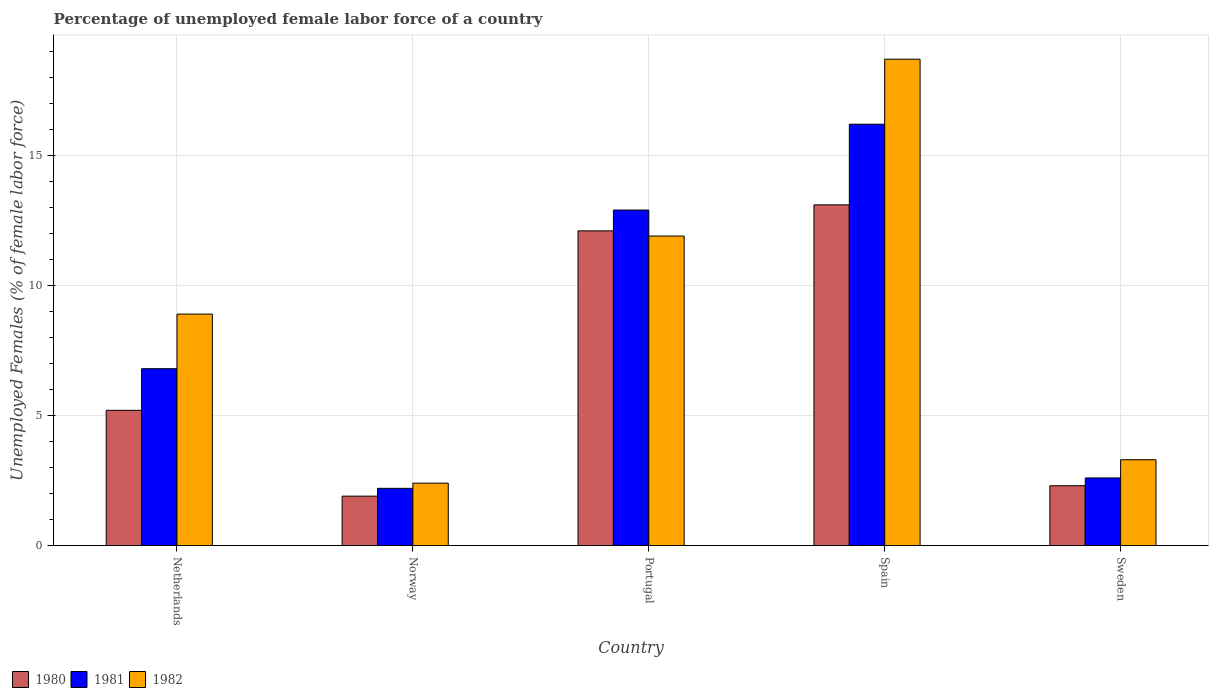How many groups of bars are there?
Ensure brevity in your answer.  5. Are the number of bars on each tick of the X-axis equal?
Provide a succinct answer. Yes. In how many cases, is the number of bars for a given country not equal to the number of legend labels?
Your response must be concise. 0. What is the percentage of unemployed female labor force in 1981 in Spain?
Provide a short and direct response. 16.2. Across all countries, what is the maximum percentage of unemployed female labor force in 1981?
Offer a very short reply. 16.2. Across all countries, what is the minimum percentage of unemployed female labor force in 1982?
Provide a succinct answer. 2.4. What is the total percentage of unemployed female labor force in 1980 in the graph?
Keep it short and to the point. 34.6. What is the difference between the percentage of unemployed female labor force in 1980 in Portugal and that in Sweden?
Provide a short and direct response. 9.8. What is the difference between the percentage of unemployed female labor force in 1982 in Spain and the percentage of unemployed female labor force in 1980 in Norway?
Make the answer very short. 16.8. What is the average percentage of unemployed female labor force in 1981 per country?
Ensure brevity in your answer.  8.14. What is the difference between the percentage of unemployed female labor force of/in 1980 and percentage of unemployed female labor force of/in 1981 in Norway?
Your response must be concise. -0.3. What is the ratio of the percentage of unemployed female labor force in 1982 in Portugal to that in Spain?
Offer a terse response. 0.64. What is the difference between the highest and the second highest percentage of unemployed female labor force in 1981?
Keep it short and to the point. 3.3. What is the difference between the highest and the lowest percentage of unemployed female labor force in 1981?
Offer a terse response. 14. What does the 2nd bar from the right in Portugal represents?
Your answer should be compact. 1981. How many bars are there?
Make the answer very short. 15. How many countries are there in the graph?
Offer a terse response. 5. Does the graph contain grids?
Offer a terse response. Yes. Where does the legend appear in the graph?
Keep it short and to the point. Bottom left. What is the title of the graph?
Ensure brevity in your answer.  Percentage of unemployed female labor force of a country. What is the label or title of the Y-axis?
Your answer should be very brief. Unemployed Females (% of female labor force). What is the Unemployed Females (% of female labor force) in 1980 in Netherlands?
Your answer should be compact. 5.2. What is the Unemployed Females (% of female labor force) in 1981 in Netherlands?
Your answer should be compact. 6.8. What is the Unemployed Females (% of female labor force) of 1982 in Netherlands?
Your answer should be compact. 8.9. What is the Unemployed Females (% of female labor force) of 1980 in Norway?
Your response must be concise. 1.9. What is the Unemployed Females (% of female labor force) in 1981 in Norway?
Give a very brief answer. 2.2. What is the Unemployed Females (% of female labor force) in 1982 in Norway?
Make the answer very short. 2.4. What is the Unemployed Females (% of female labor force) in 1980 in Portugal?
Give a very brief answer. 12.1. What is the Unemployed Females (% of female labor force) in 1981 in Portugal?
Your answer should be compact. 12.9. What is the Unemployed Females (% of female labor force) in 1982 in Portugal?
Your response must be concise. 11.9. What is the Unemployed Females (% of female labor force) in 1980 in Spain?
Your answer should be compact. 13.1. What is the Unemployed Females (% of female labor force) of 1981 in Spain?
Your response must be concise. 16.2. What is the Unemployed Females (% of female labor force) of 1982 in Spain?
Offer a terse response. 18.7. What is the Unemployed Females (% of female labor force) in 1980 in Sweden?
Offer a very short reply. 2.3. What is the Unemployed Females (% of female labor force) of 1981 in Sweden?
Give a very brief answer. 2.6. What is the Unemployed Females (% of female labor force) in 1982 in Sweden?
Provide a short and direct response. 3.3. Across all countries, what is the maximum Unemployed Females (% of female labor force) of 1980?
Provide a succinct answer. 13.1. Across all countries, what is the maximum Unemployed Females (% of female labor force) in 1981?
Provide a short and direct response. 16.2. Across all countries, what is the maximum Unemployed Females (% of female labor force) in 1982?
Provide a short and direct response. 18.7. Across all countries, what is the minimum Unemployed Females (% of female labor force) of 1980?
Offer a terse response. 1.9. Across all countries, what is the minimum Unemployed Females (% of female labor force) of 1981?
Ensure brevity in your answer.  2.2. Across all countries, what is the minimum Unemployed Females (% of female labor force) in 1982?
Provide a short and direct response. 2.4. What is the total Unemployed Females (% of female labor force) in 1980 in the graph?
Your response must be concise. 34.6. What is the total Unemployed Females (% of female labor force) in 1981 in the graph?
Make the answer very short. 40.7. What is the total Unemployed Females (% of female labor force) of 1982 in the graph?
Your response must be concise. 45.2. What is the difference between the Unemployed Females (% of female labor force) of 1982 in Netherlands and that in Norway?
Give a very brief answer. 6.5. What is the difference between the Unemployed Females (% of female labor force) in 1980 in Netherlands and that in Portugal?
Your response must be concise. -6.9. What is the difference between the Unemployed Females (% of female labor force) in 1981 in Netherlands and that in Portugal?
Provide a succinct answer. -6.1. What is the difference between the Unemployed Females (% of female labor force) of 1982 in Netherlands and that in Spain?
Provide a short and direct response. -9.8. What is the difference between the Unemployed Females (% of female labor force) of 1981 in Norway and that in Portugal?
Ensure brevity in your answer.  -10.7. What is the difference between the Unemployed Females (% of female labor force) of 1982 in Norway and that in Portugal?
Give a very brief answer. -9.5. What is the difference between the Unemployed Females (% of female labor force) of 1982 in Norway and that in Spain?
Provide a short and direct response. -16.3. What is the difference between the Unemployed Females (% of female labor force) in 1982 in Norway and that in Sweden?
Ensure brevity in your answer.  -0.9. What is the difference between the Unemployed Females (% of female labor force) of 1980 in Portugal and that in Spain?
Offer a terse response. -1. What is the difference between the Unemployed Females (% of female labor force) in 1981 in Portugal and that in Spain?
Provide a succinct answer. -3.3. What is the difference between the Unemployed Females (% of female labor force) in 1981 in Portugal and that in Sweden?
Keep it short and to the point. 10.3. What is the difference between the Unemployed Females (% of female labor force) of 1980 in Spain and that in Sweden?
Keep it short and to the point. 10.8. What is the difference between the Unemployed Females (% of female labor force) of 1980 in Netherlands and the Unemployed Females (% of female labor force) of 1982 in Norway?
Provide a short and direct response. 2.8. What is the difference between the Unemployed Females (% of female labor force) in 1981 in Netherlands and the Unemployed Females (% of female labor force) in 1982 in Norway?
Give a very brief answer. 4.4. What is the difference between the Unemployed Females (% of female labor force) of 1980 in Netherlands and the Unemployed Females (% of female labor force) of 1981 in Portugal?
Your response must be concise. -7.7. What is the difference between the Unemployed Females (% of female labor force) in 1980 in Netherlands and the Unemployed Females (% of female labor force) in 1982 in Portugal?
Ensure brevity in your answer.  -6.7. What is the difference between the Unemployed Females (% of female labor force) of 1981 in Netherlands and the Unemployed Females (% of female labor force) of 1982 in Portugal?
Provide a succinct answer. -5.1. What is the difference between the Unemployed Females (% of female labor force) of 1980 in Netherlands and the Unemployed Females (% of female labor force) of 1981 in Spain?
Your answer should be compact. -11. What is the difference between the Unemployed Females (% of female labor force) in 1980 in Netherlands and the Unemployed Females (% of female labor force) in 1982 in Spain?
Offer a very short reply. -13.5. What is the difference between the Unemployed Females (% of female labor force) of 1980 in Netherlands and the Unemployed Females (% of female labor force) of 1982 in Sweden?
Give a very brief answer. 1.9. What is the difference between the Unemployed Females (% of female labor force) in 1980 in Norway and the Unemployed Females (% of female labor force) in 1981 in Portugal?
Your answer should be very brief. -11. What is the difference between the Unemployed Females (% of female labor force) of 1980 in Norway and the Unemployed Females (% of female labor force) of 1982 in Portugal?
Your response must be concise. -10. What is the difference between the Unemployed Females (% of female labor force) in 1980 in Norway and the Unemployed Females (% of female labor force) in 1981 in Spain?
Your response must be concise. -14.3. What is the difference between the Unemployed Females (% of female labor force) in 1980 in Norway and the Unemployed Females (% of female labor force) in 1982 in Spain?
Make the answer very short. -16.8. What is the difference between the Unemployed Females (% of female labor force) in 1981 in Norway and the Unemployed Females (% of female labor force) in 1982 in Spain?
Provide a short and direct response. -16.5. What is the difference between the Unemployed Females (% of female labor force) in 1980 in Norway and the Unemployed Females (% of female labor force) in 1981 in Sweden?
Your response must be concise. -0.7. What is the difference between the Unemployed Females (% of female labor force) in 1981 in Norway and the Unemployed Females (% of female labor force) in 1982 in Sweden?
Your response must be concise. -1.1. What is the difference between the Unemployed Females (% of female labor force) in 1981 in Portugal and the Unemployed Females (% of female labor force) in 1982 in Sweden?
Offer a terse response. 9.6. What is the difference between the Unemployed Females (% of female labor force) of 1980 in Spain and the Unemployed Females (% of female labor force) of 1982 in Sweden?
Your answer should be compact. 9.8. What is the average Unemployed Females (% of female labor force) of 1980 per country?
Your answer should be compact. 6.92. What is the average Unemployed Females (% of female labor force) of 1981 per country?
Provide a succinct answer. 8.14. What is the average Unemployed Females (% of female labor force) in 1982 per country?
Your answer should be very brief. 9.04. What is the difference between the Unemployed Females (% of female labor force) in 1980 and Unemployed Females (% of female labor force) in 1982 in Netherlands?
Provide a succinct answer. -3.7. What is the difference between the Unemployed Females (% of female labor force) of 1981 and Unemployed Females (% of female labor force) of 1982 in Netherlands?
Give a very brief answer. -2.1. What is the difference between the Unemployed Females (% of female labor force) in 1980 and Unemployed Females (% of female labor force) in 1981 in Portugal?
Ensure brevity in your answer.  -0.8. What is the difference between the Unemployed Females (% of female labor force) in 1980 and Unemployed Females (% of female labor force) in 1982 in Portugal?
Give a very brief answer. 0.2. What is the difference between the Unemployed Females (% of female labor force) of 1980 and Unemployed Females (% of female labor force) of 1982 in Spain?
Your answer should be compact. -5.6. What is the difference between the Unemployed Females (% of female labor force) in 1980 and Unemployed Females (% of female labor force) in 1981 in Sweden?
Make the answer very short. -0.3. What is the difference between the Unemployed Females (% of female labor force) of 1980 and Unemployed Females (% of female labor force) of 1982 in Sweden?
Make the answer very short. -1. What is the ratio of the Unemployed Females (% of female labor force) in 1980 in Netherlands to that in Norway?
Ensure brevity in your answer.  2.74. What is the ratio of the Unemployed Females (% of female labor force) of 1981 in Netherlands to that in Norway?
Ensure brevity in your answer.  3.09. What is the ratio of the Unemployed Females (% of female labor force) of 1982 in Netherlands to that in Norway?
Offer a terse response. 3.71. What is the ratio of the Unemployed Females (% of female labor force) of 1980 in Netherlands to that in Portugal?
Provide a succinct answer. 0.43. What is the ratio of the Unemployed Females (% of female labor force) of 1981 in Netherlands to that in Portugal?
Keep it short and to the point. 0.53. What is the ratio of the Unemployed Females (% of female labor force) of 1982 in Netherlands to that in Portugal?
Keep it short and to the point. 0.75. What is the ratio of the Unemployed Females (% of female labor force) of 1980 in Netherlands to that in Spain?
Make the answer very short. 0.4. What is the ratio of the Unemployed Females (% of female labor force) in 1981 in Netherlands to that in Spain?
Make the answer very short. 0.42. What is the ratio of the Unemployed Females (% of female labor force) of 1982 in Netherlands to that in Spain?
Your answer should be very brief. 0.48. What is the ratio of the Unemployed Females (% of female labor force) of 1980 in Netherlands to that in Sweden?
Make the answer very short. 2.26. What is the ratio of the Unemployed Females (% of female labor force) in 1981 in Netherlands to that in Sweden?
Provide a succinct answer. 2.62. What is the ratio of the Unemployed Females (% of female labor force) of 1982 in Netherlands to that in Sweden?
Your answer should be compact. 2.7. What is the ratio of the Unemployed Females (% of female labor force) of 1980 in Norway to that in Portugal?
Your answer should be compact. 0.16. What is the ratio of the Unemployed Females (% of female labor force) of 1981 in Norway to that in Portugal?
Offer a very short reply. 0.17. What is the ratio of the Unemployed Females (% of female labor force) of 1982 in Norway to that in Portugal?
Offer a terse response. 0.2. What is the ratio of the Unemployed Females (% of female labor force) in 1980 in Norway to that in Spain?
Offer a very short reply. 0.14. What is the ratio of the Unemployed Females (% of female labor force) of 1981 in Norway to that in Spain?
Offer a terse response. 0.14. What is the ratio of the Unemployed Females (% of female labor force) of 1982 in Norway to that in Spain?
Offer a very short reply. 0.13. What is the ratio of the Unemployed Females (% of female labor force) in 1980 in Norway to that in Sweden?
Provide a short and direct response. 0.83. What is the ratio of the Unemployed Females (% of female labor force) of 1981 in Norway to that in Sweden?
Your answer should be compact. 0.85. What is the ratio of the Unemployed Females (% of female labor force) in 1982 in Norway to that in Sweden?
Keep it short and to the point. 0.73. What is the ratio of the Unemployed Females (% of female labor force) in 1980 in Portugal to that in Spain?
Offer a very short reply. 0.92. What is the ratio of the Unemployed Females (% of female labor force) in 1981 in Portugal to that in Spain?
Give a very brief answer. 0.8. What is the ratio of the Unemployed Females (% of female labor force) of 1982 in Portugal to that in Spain?
Provide a succinct answer. 0.64. What is the ratio of the Unemployed Females (% of female labor force) of 1980 in Portugal to that in Sweden?
Your response must be concise. 5.26. What is the ratio of the Unemployed Females (% of female labor force) in 1981 in Portugal to that in Sweden?
Ensure brevity in your answer.  4.96. What is the ratio of the Unemployed Females (% of female labor force) in 1982 in Portugal to that in Sweden?
Keep it short and to the point. 3.61. What is the ratio of the Unemployed Females (% of female labor force) of 1980 in Spain to that in Sweden?
Keep it short and to the point. 5.7. What is the ratio of the Unemployed Females (% of female labor force) in 1981 in Spain to that in Sweden?
Offer a very short reply. 6.23. What is the ratio of the Unemployed Females (% of female labor force) of 1982 in Spain to that in Sweden?
Ensure brevity in your answer.  5.67. What is the difference between the highest and the second highest Unemployed Females (% of female labor force) of 1980?
Provide a short and direct response. 1. What is the difference between the highest and the second highest Unemployed Females (% of female labor force) in 1982?
Your answer should be very brief. 6.8. What is the difference between the highest and the lowest Unemployed Females (% of female labor force) in 1982?
Offer a very short reply. 16.3. 